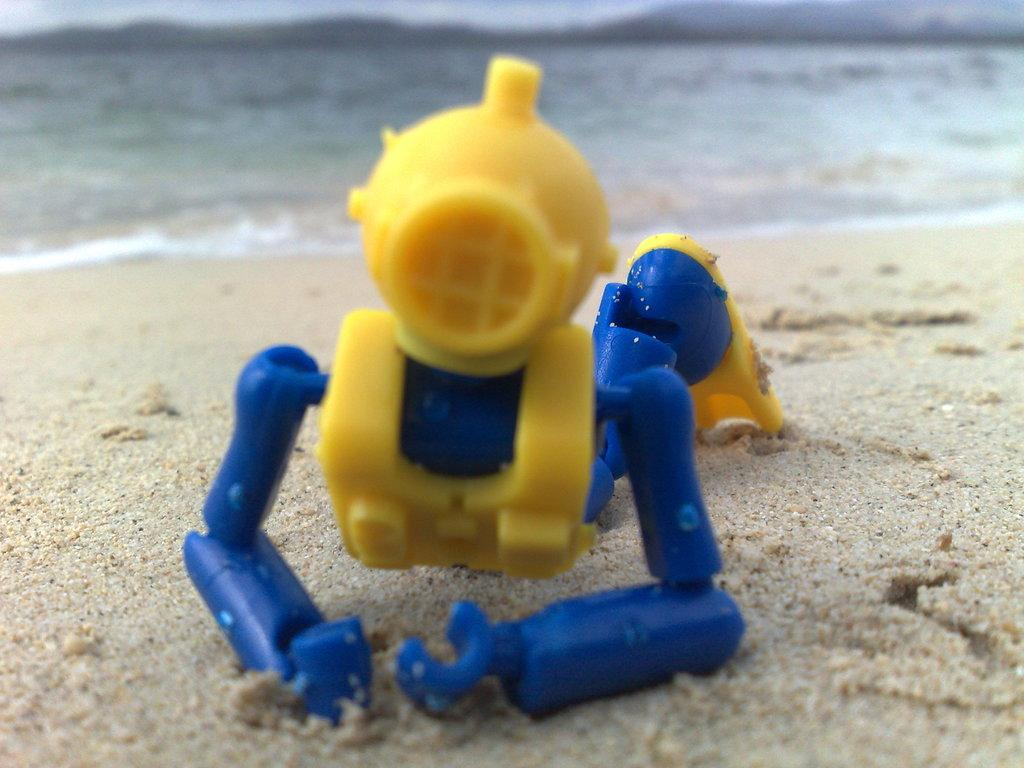What is the main subject in the center of the image? There is a toy in the center of the image. What is the toy placed on? The toy is placed on sand. What can be seen in the background of the image? There is water visible in the background of the image. What type of pencil is being used to draw in the sand in the image? There is no pencil present in the image, and no drawing activity is taking place. 